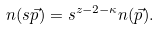Convert formula to latex. <formula><loc_0><loc_0><loc_500><loc_500>n ( s \vec { p } ) = s ^ { z - 2 - \kappa } n ( \vec { p } ) .</formula> 